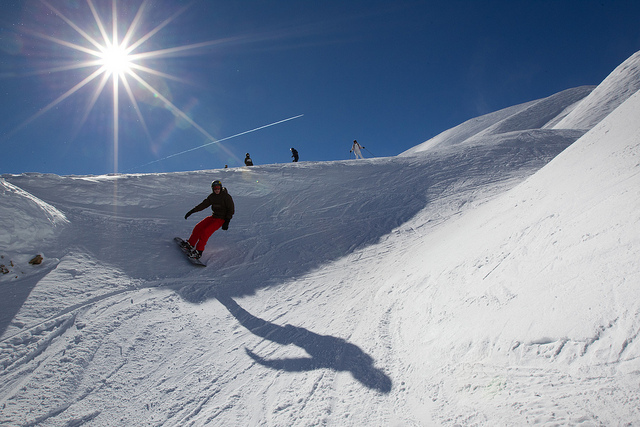How many snowboarders are in the picture? 1 